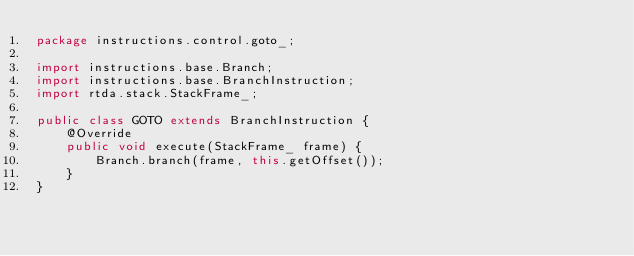<code> <loc_0><loc_0><loc_500><loc_500><_Java_>package instructions.control.goto_;

import instructions.base.Branch;
import instructions.base.BranchInstruction;
import rtda.stack.StackFrame_;

public class GOTO extends BranchInstruction {
    @Override
    public void execute(StackFrame_ frame) {
        Branch.branch(frame, this.getOffset());
    }
}
</code> 